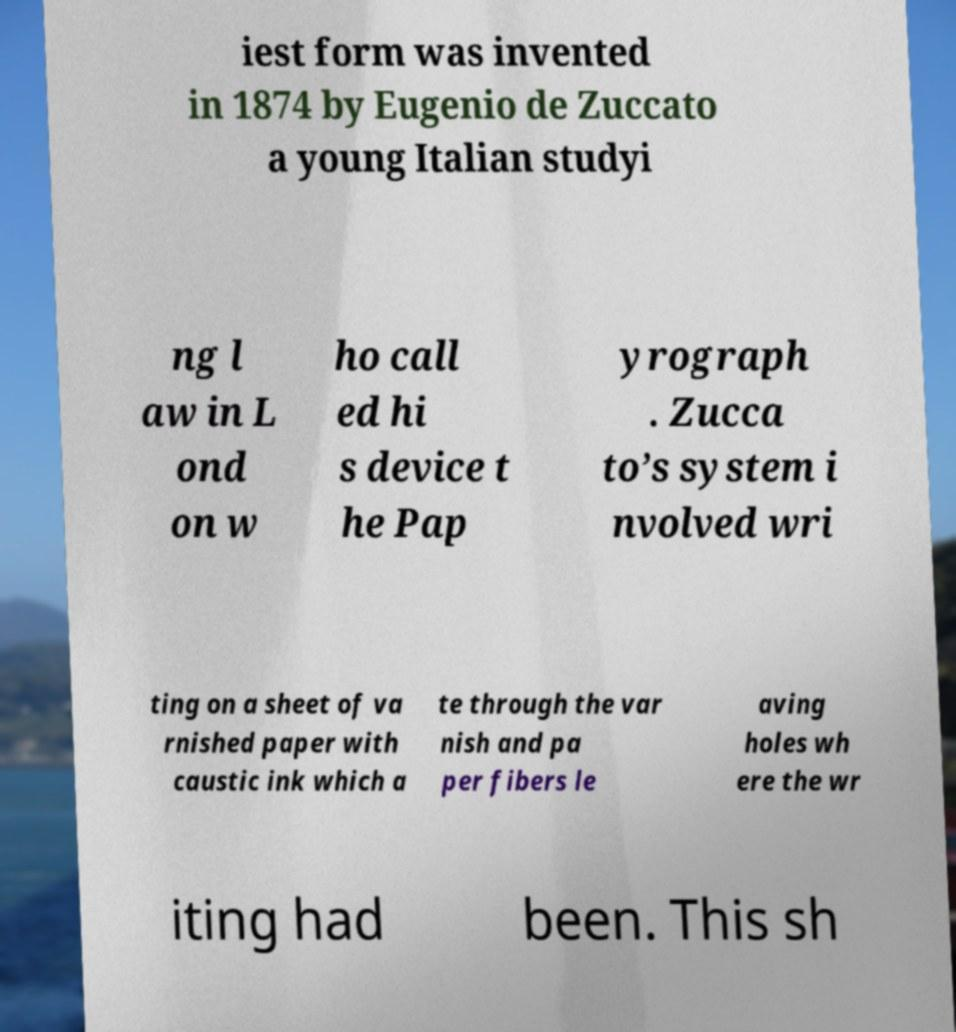There's text embedded in this image that I need extracted. Can you transcribe it verbatim? iest form was invented in 1874 by Eugenio de Zuccato a young Italian studyi ng l aw in L ond on w ho call ed hi s device t he Pap yrograph . Zucca to’s system i nvolved wri ting on a sheet of va rnished paper with caustic ink which a te through the var nish and pa per fibers le aving holes wh ere the wr iting had been. This sh 